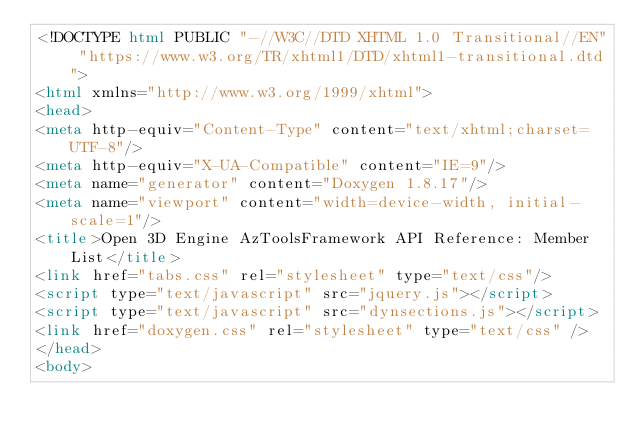<code> <loc_0><loc_0><loc_500><loc_500><_HTML_><!DOCTYPE html PUBLIC "-//W3C//DTD XHTML 1.0 Transitional//EN" "https://www.w3.org/TR/xhtml1/DTD/xhtml1-transitional.dtd">
<html xmlns="http://www.w3.org/1999/xhtml">
<head>
<meta http-equiv="Content-Type" content="text/xhtml;charset=UTF-8"/>
<meta http-equiv="X-UA-Compatible" content="IE=9"/>
<meta name="generator" content="Doxygen 1.8.17"/>
<meta name="viewport" content="width=device-width, initial-scale=1"/>
<title>Open 3D Engine AzToolsFramework API Reference: Member List</title>
<link href="tabs.css" rel="stylesheet" type="text/css"/>
<script type="text/javascript" src="jquery.js"></script>
<script type="text/javascript" src="dynsections.js"></script>
<link href="doxygen.css" rel="stylesheet" type="text/css" />
</head>
<body></code> 